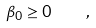Convert formula to latex. <formula><loc_0><loc_0><loc_500><loc_500>\beta _ { 0 } \geq 0 \quad ,</formula> 